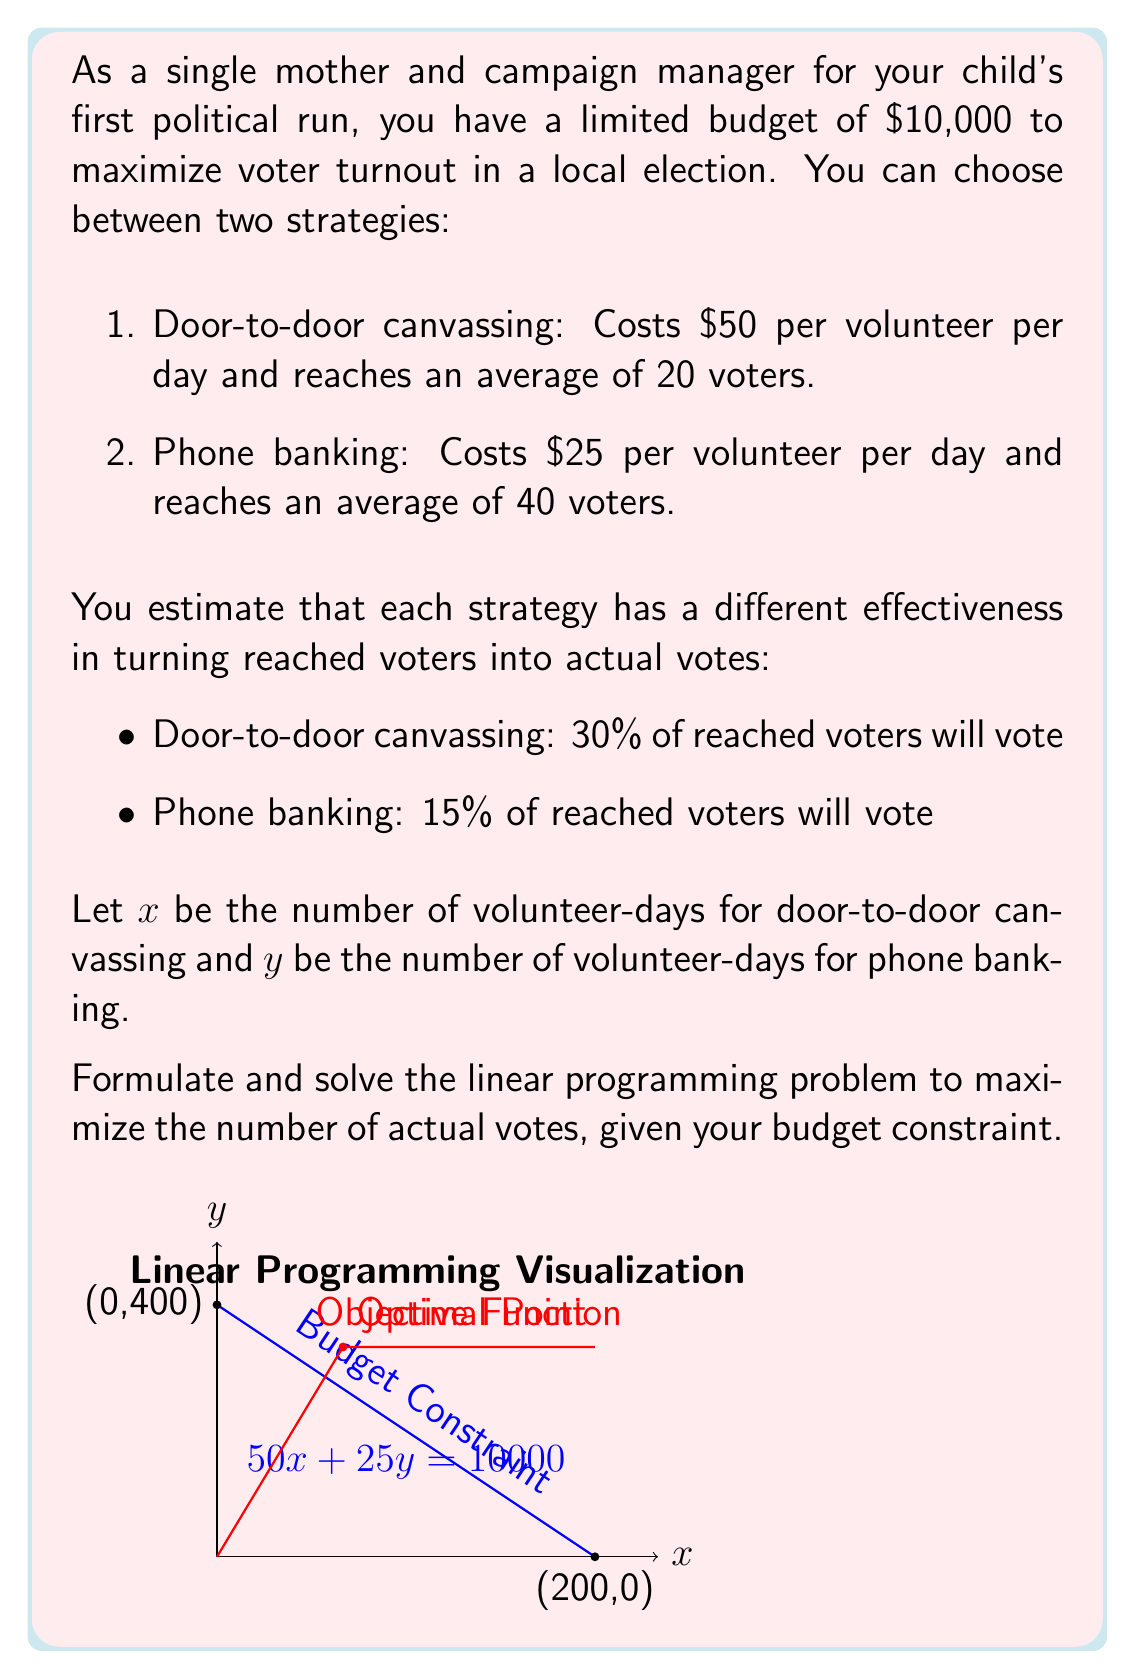Can you answer this question? Let's approach this step-by-step:

1) First, we need to formulate our objective function. We want to maximize the number of actual votes:
   
   Maximize: $Z = 0.3(20x) + 0.15(40y) = 6x + 6y$

2) Now, let's formulate our constraints:
   
   Budget constraint: $50x + 25y \leq 10000$
   Non-negativity: $x \geq 0, y \geq 0$

3) Our linear programming problem is now:

   Maximize: $Z = 6x + 6y$
   Subject to:
   $50x + 25y \leq 10000$
   $x \geq 0, y \geq 0$

4) To solve this, we can use the graphical method. The feasible region is bounded by the budget constraint line and the axes.

5) The corner points of the feasible region are:
   (0, 0), (0, 400), (200, 0)

6) Evaluating the objective function at these points:
   At (0, 0): $Z = 0$
   At (0, 400): $Z = 2400$
   At (200, 0): $Z = 1200$

7) However, we also need to check the point where the objective function line intersects the budget constraint line. This occurs when:

   $50x + 25y = 10000$
   $6x = 6y$

   Solving these simultaneously:
   $x = 66.67, y = 66.67$

8) At this point: $Z = 6(66.67) + 6(66.67) = 800$

Therefore, the maximum number of votes is achieved at the point (0, 400), which represents allocating all resources to phone banking.
Answer: 400 volunteer-days of phone banking, yielding 2400 votes 